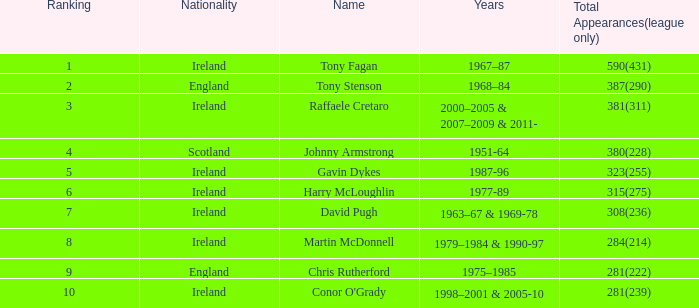How many overall appearances (league only) are named gavin dykes? 323(255). 